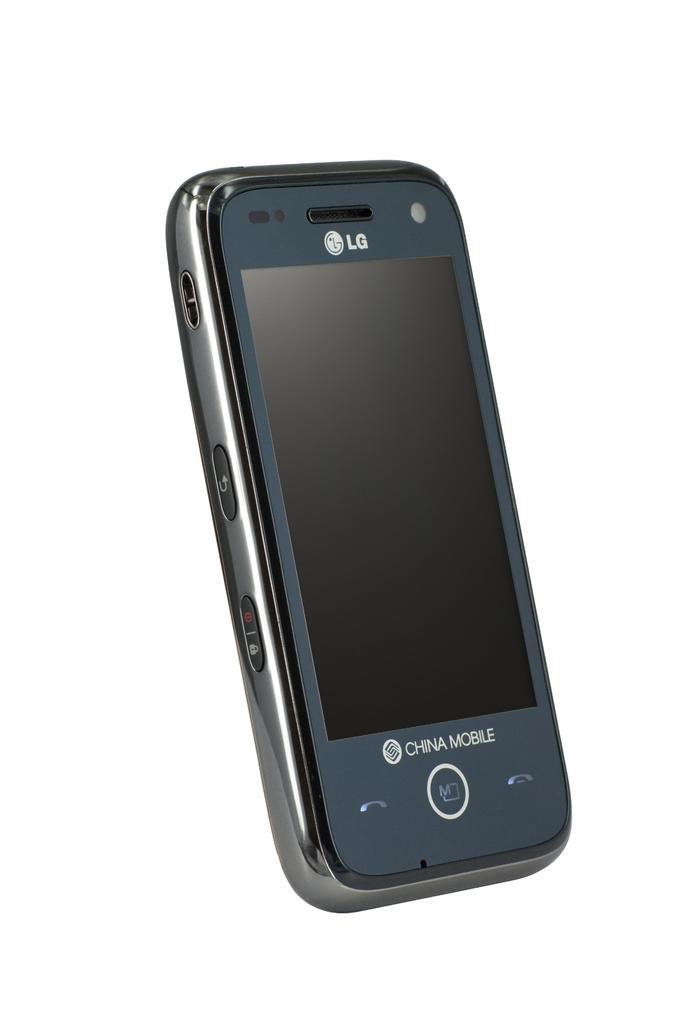<image>
Write a terse but informative summary of the picture. A Chinese Mobile LG phone in front of a white background. 